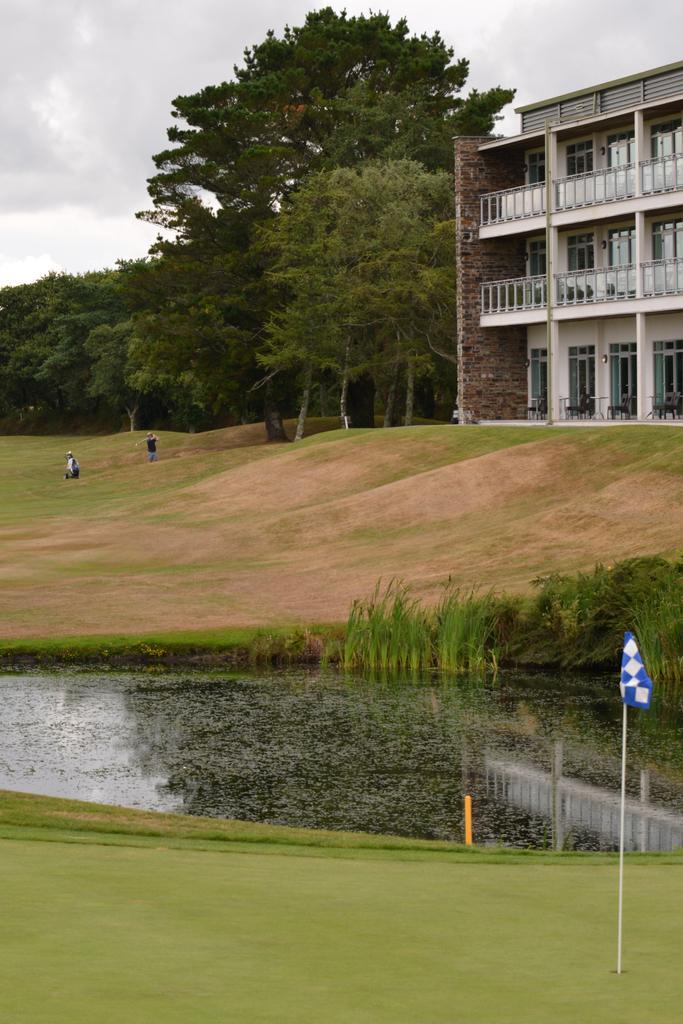In one or two sentences, can you explain what this image depicts? In this image I can see blue and white color flag. Back Side I can see building,trees and two persons. In front I can see water. The sky is in white color. 